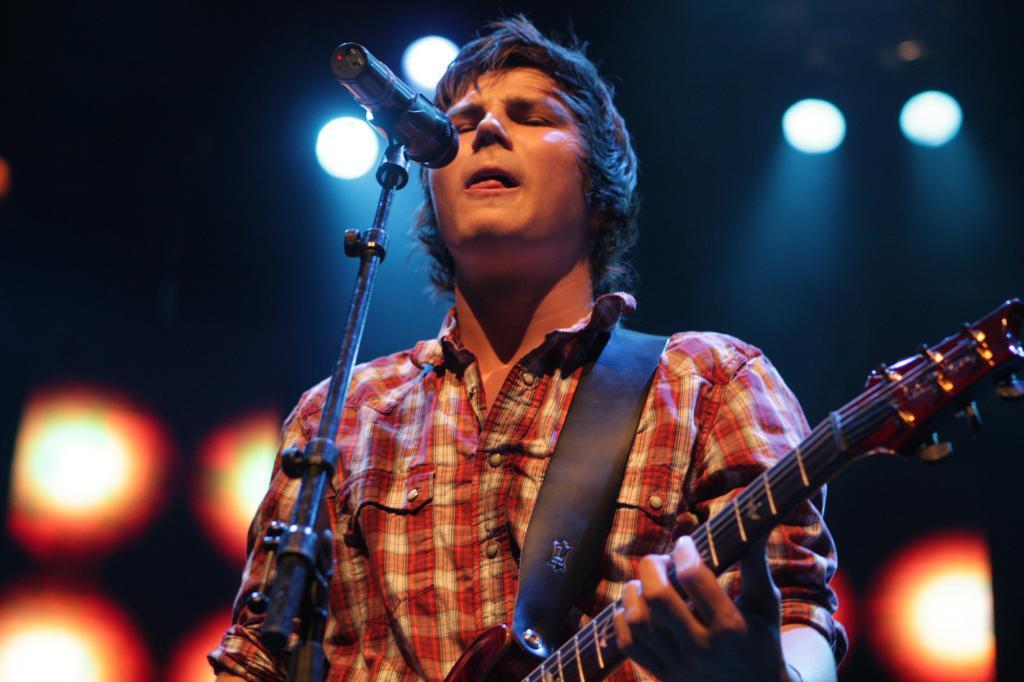How would you summarize this image in a sentence or two? It is a picture where one person is present in center of it, holding a guitar and wearing a shirt standing in front of the microphone. 